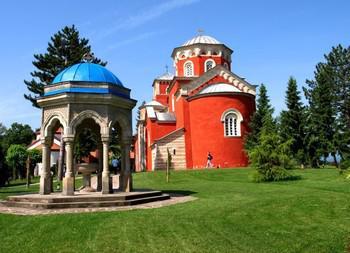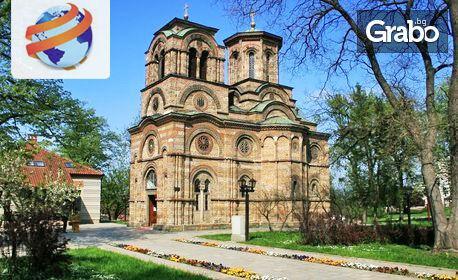The first image is the image on the left, the second image is the image on the right. Analyze the images presented: Is the assertion "At least one of the buildings in the image on the left is bright orange." valid? Answer yes or no. Yes. The first image is the image on the left, the second image is the image on the right. Given the left and right images, does the statement "Left image shows a reddish-orange building with a dome-topped tower with flat sides featuring round-topped windows." hold true? Answer yes or no. Yes. 